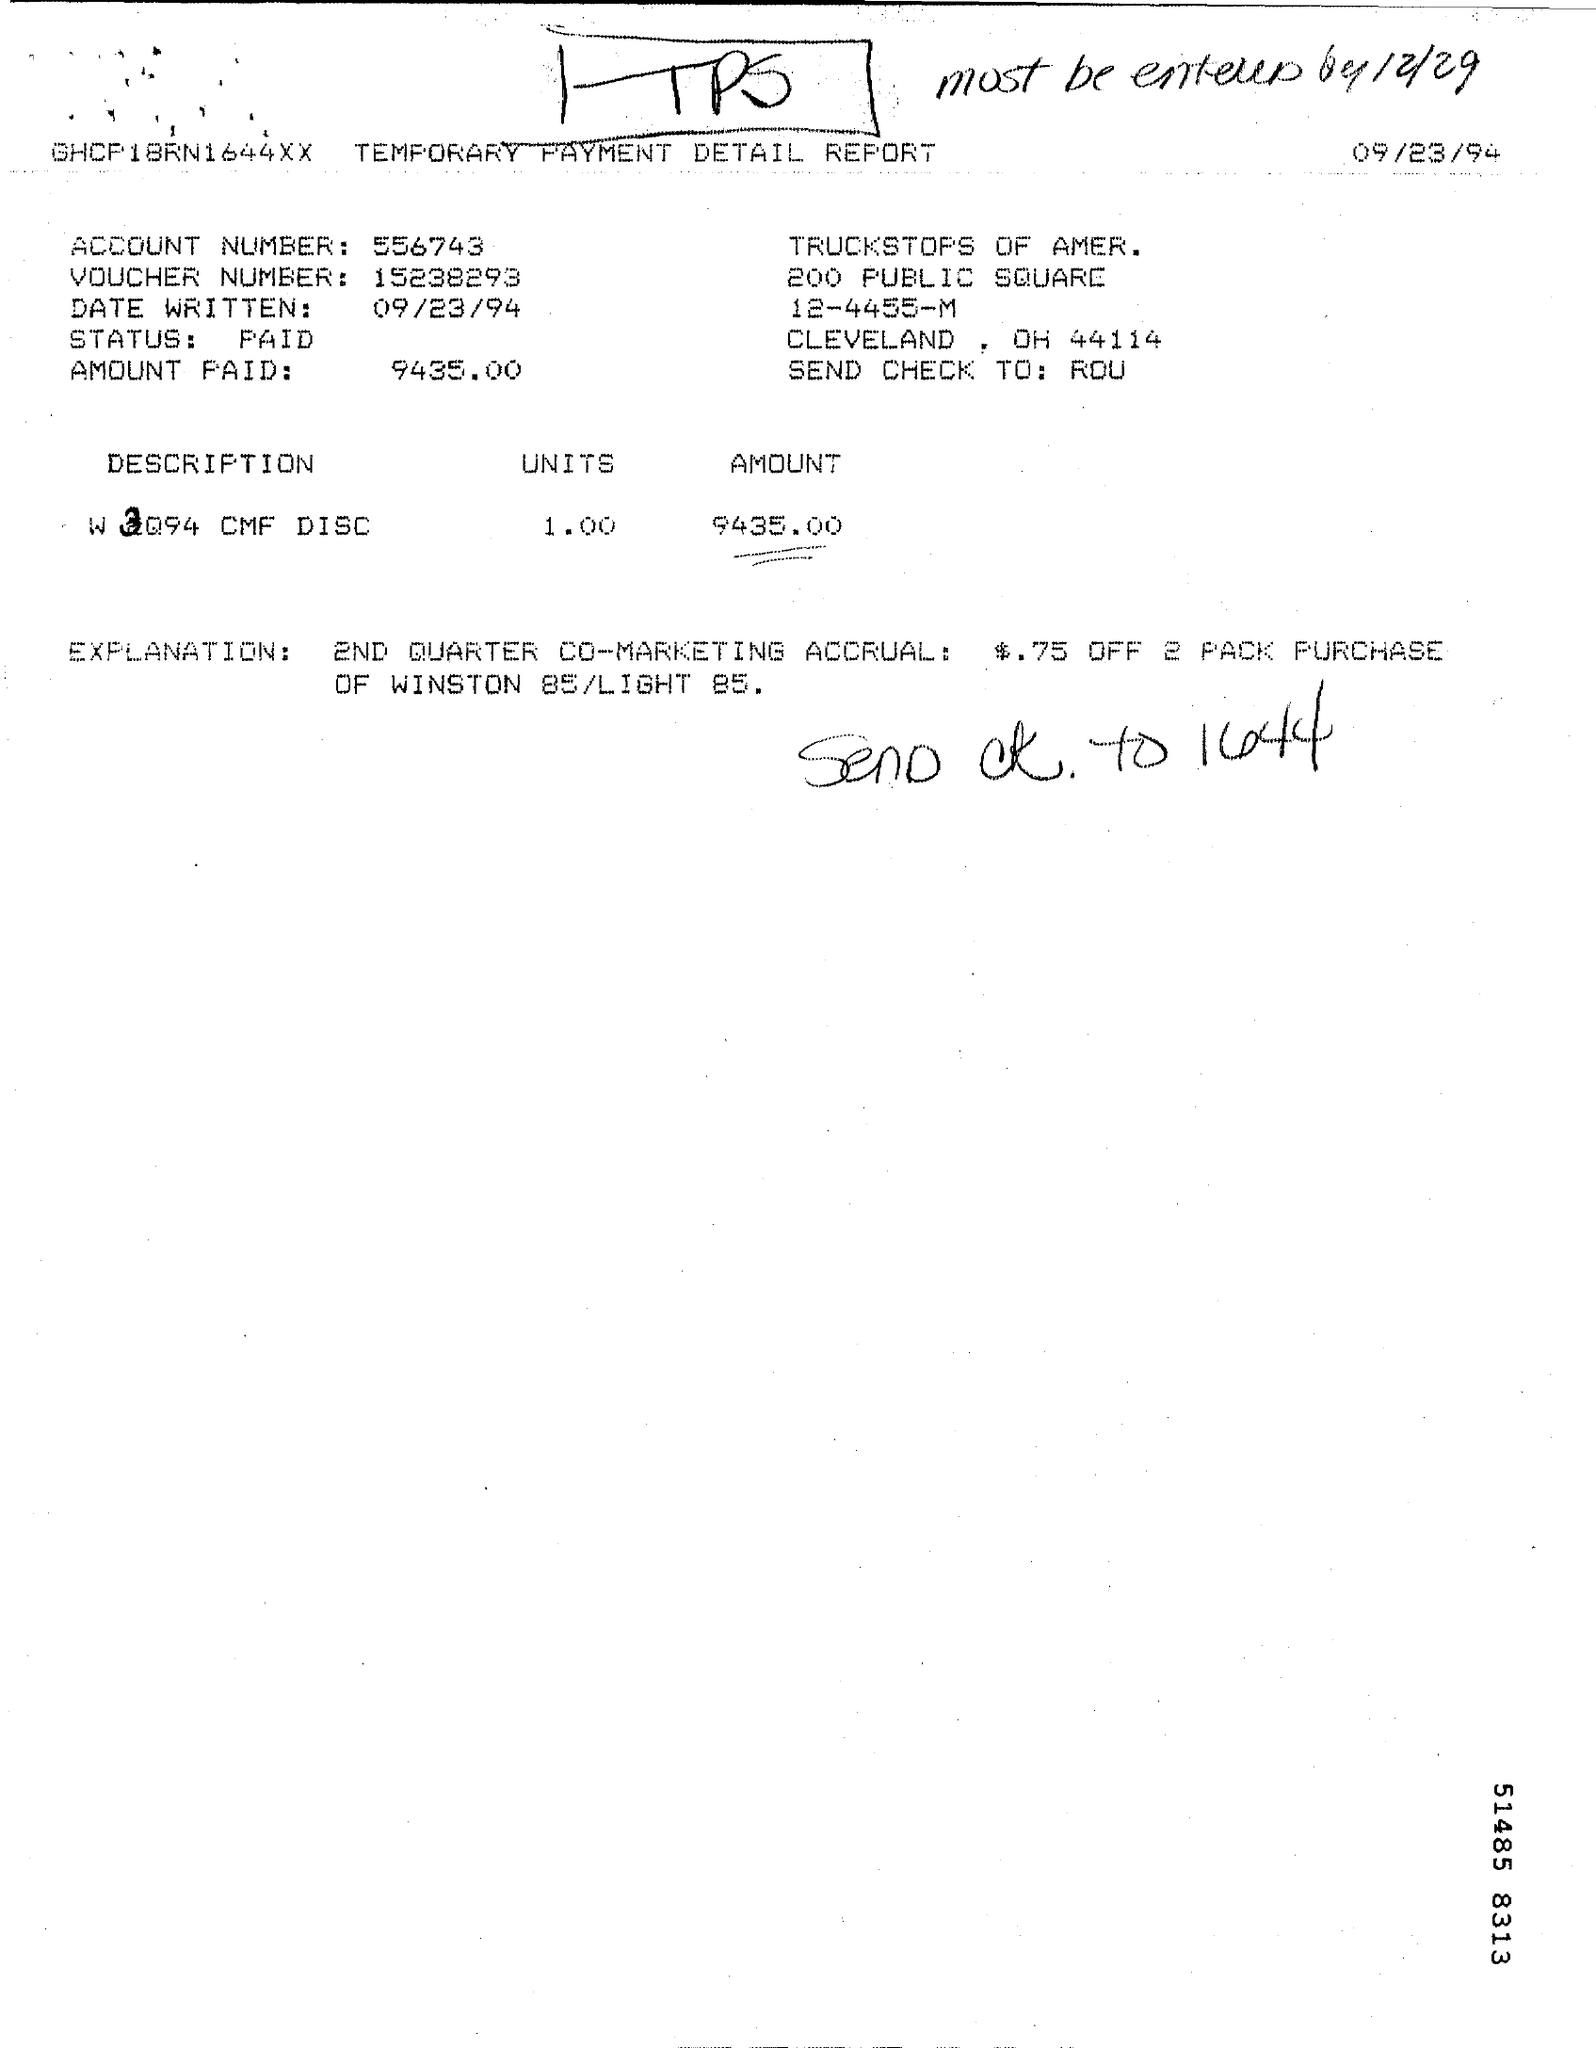What is the account number mentioned in the given page ?
Offer a very short reply. 556743. What is the voucher number mentioned in the given page ?
Your answer should be very brief. 15238293. What is the date written in the given page ?
Make the answer very short. 09/23/94. What is the status shown in the given page ?
Provide a succinct answer. PAID. How much amount is paid as shown in the report ?
Provide a succinct answer. 9435.00. 